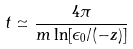Convert formula to latex. <formula><loc_0><loc_0><loc_500><loc_500>t \simeq \frac { 4 \pi } { m \ln [ \epsilon _ { 0 } / ( - z ) ] }</formula> 